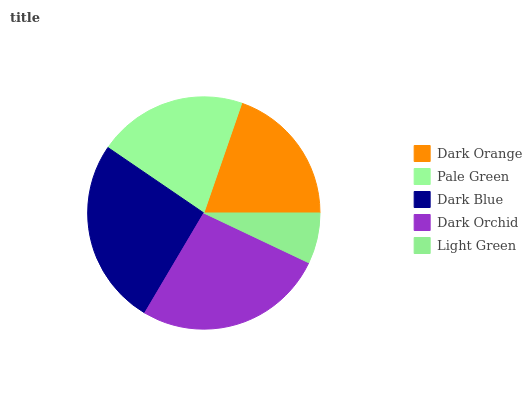Is Light Green the minimum?
Answer yes or no. Yes. Is Dark Orchid the maximum?
Answer yes or no. Yes. Is Pale Green the minimum?
Answer yes or no. No. Is Pale Green the maximum?
Answer yes or no. No. Is Pale Green greater than Dark Orange?
Answer yes or no. Yes. Is Dark Orange less than Pale Green?
Answer yes or no. Yes. Is Dark Orange greater than Pale Green?
Answer yes or no. No. Is Pale Green less than Dark Orange?
Answer yes or no. No. Is Pale Green the high median?
Answer yes or no. Yes. Is Pale Green the low median?
Answer yes or no. Yes. Is Dark Blue the high median?
Answer yes or no. No. Is Dark Orchid the low median?
Answer yes or no. No. 